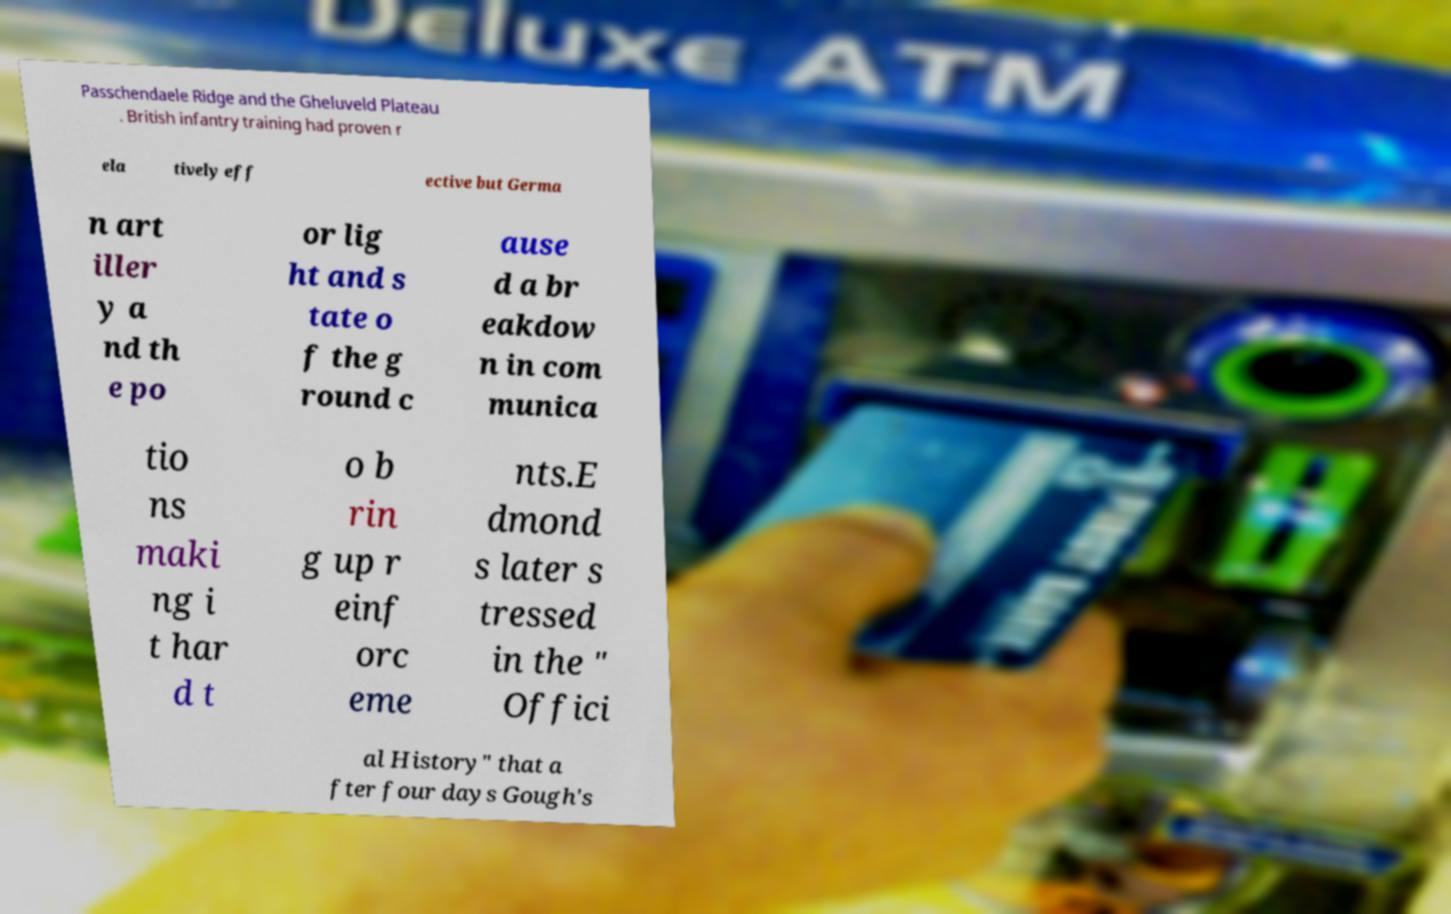What messages or text are displayed in this image? I need them in a readable, typed format. Passchendaele Ridge and the Gheluveld Plateau . British infantry training had proven r ela tively eff ective but Germa n art iller y a nd th e po or lig ht and s tate o f the g round c ause d a br eakdow n in com munica tio ns maki ng i t har d t o b rin g up r einf orc eme nts.E dmond s later s tressed in the " Offici al History" that a fter four days Gough's 